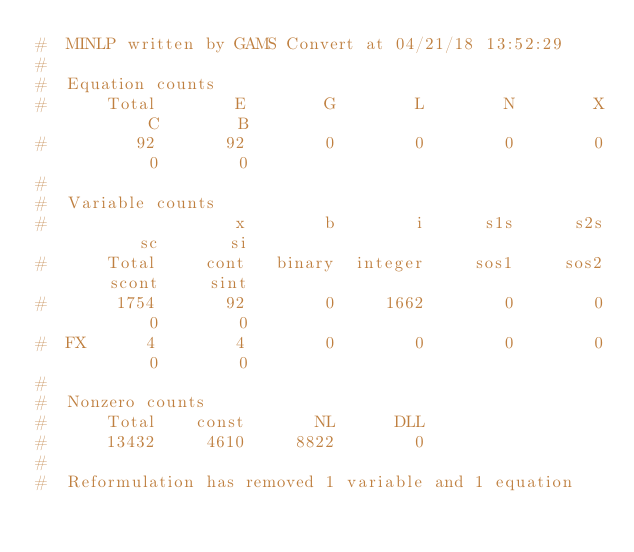Convert code to text. <code><loc_0><loc_0><loc_500><loc_500><_Python_>#  MINLP written by GAMS Convert at 04/21/18 13:52:29
#  
#  Equation counts
#      Total        E        G        L        N        X        C        B
#         92       92        0        0        0        0        0        0
#  
#  Variable counts
#                   x        b        i      s1s      s2s       sc       si
#      Total     cont   binary  integer     sos1     sos2    scont     sint
#       1754       92        0     1662        0        0        0        0
#  FX      4        4        0        0        0        0        0        0
#  
#  Nonzero counts
#      Total    const       NL      DLL
#      13432     4610     8822        0
# 
#  Reformulation has removed 1 variable and 1 equation

</code> 